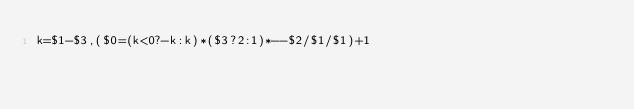Convert code to text. <code><loc_0><loc_0><loc_500><loc_500><_Awk_>k=$1-$3,($0=(k<0?-k:k)*($3?2:1)*--$2/$1/$1)+1</code> 